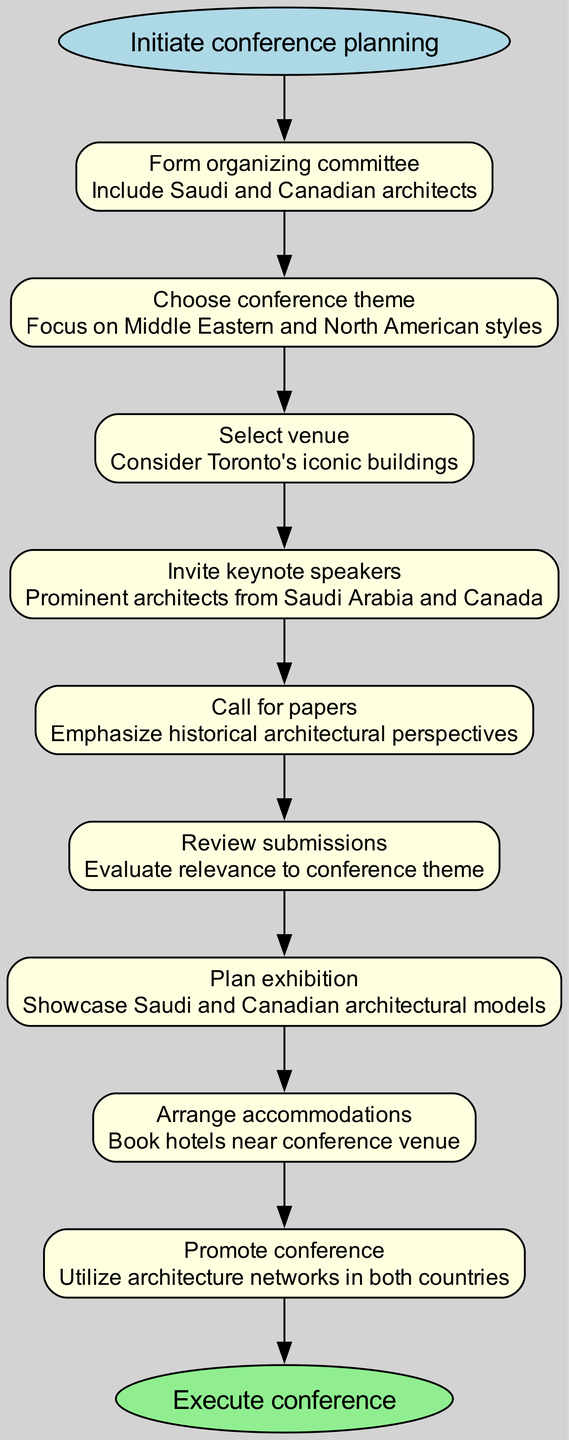What is the first step in organizing the conference? The first step listed in the flow chart is "Initiate conference planning," which is noted at the start node.
Answer: Initiate conference planning How many steps are involved in the conference planning? The flow chart includes a total of eight steps before the end node, as counted from the list of steps included in the diagram.
Answer: 8 What is the theme of the conference? The theme chosen for the conference is "Focus on Middle Eastern and North American styles," which is specified in the second step of the flow chart.
Answer: Focus on Middle Eastern and North American styles In which city is the venue selected? The venue is to be selected in "Toronto," which is mentioned in the step detailing the selection of the venue.
Answer: Toronto Which types of architects are invited as keynote speakers? The conference invites "Prominent architects from Saudi Arabia and Canada" as keynote speakers, as stated in the relevant step.
Answer: Prominent architects from Saudi Arabia and Canada What is done after calling for papers? After the "Call for papers," the next step is to "Review submissions," which evaluates the relevance of the papers submitted to the conference theme.
Answer: Review submissions How does the conference promote itself? The promotion of the conference is carried out by utilizing "architecture networks in both countries," as detailed in the corresponding step.
Answer: Utilize architecture networks in both countries What is the final step in the process? The final step outlined in the flow chart is to "Execute conference," marking the conclusion of all prior planning and arrangements.
Answer: Execute conference 